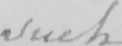Can you read and transcribe this handwriting? such 